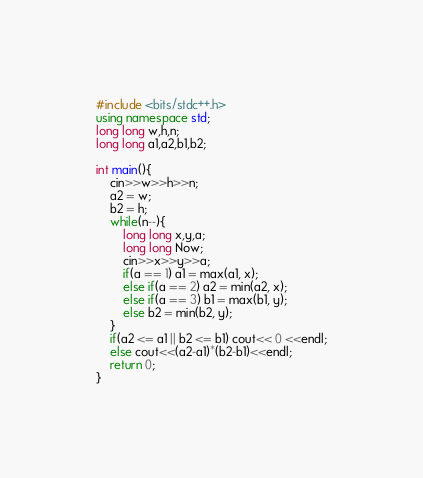Convert code to text. <code><loc_0><loc_0><loc_500><loc_500><_C++_>#include <bits/stdc++.h>
using namespace std;
long long w,h,n;
long long a1,a2,b1,b2;

int main(){
	cin>>w>>h>>n;
	a2 = w;
	b2 = h;
	while(n--){
		long long x,y,a;
		long long Now;
		cin>>x>>y>>a;
		if(a == 1) a1 = max(a1, x);
		else if(a == 2) a2 = min(a2, x);
		else if(a == 3) b1 = max(b1, y);
		else b2 = min(b2, y);
	}	
	if(a2 <= a1 || b2 <= b1) cout<< 0 <<endl;
	else cout<<(a2-a1)*(b2-b1)<<endl;
	return 0;
}</code> 